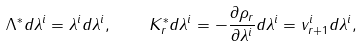<formula> <loc_0><loc_0><loc_500><loc_500>\Lambda ^ { \ast } d \lambda ^ { i } = \lambda ^ { i } d \lambda ^ { i } , \quad K _ { r } ^ { \ast } d \lambda ^ { i } = - \frac { \partial \rho _ { r } } { \partial \lambda ^ { i } } d \lambda ^ { i } = v _ { r + 1 } ^ { i } d \lambda ^ { i } ,</formula> 